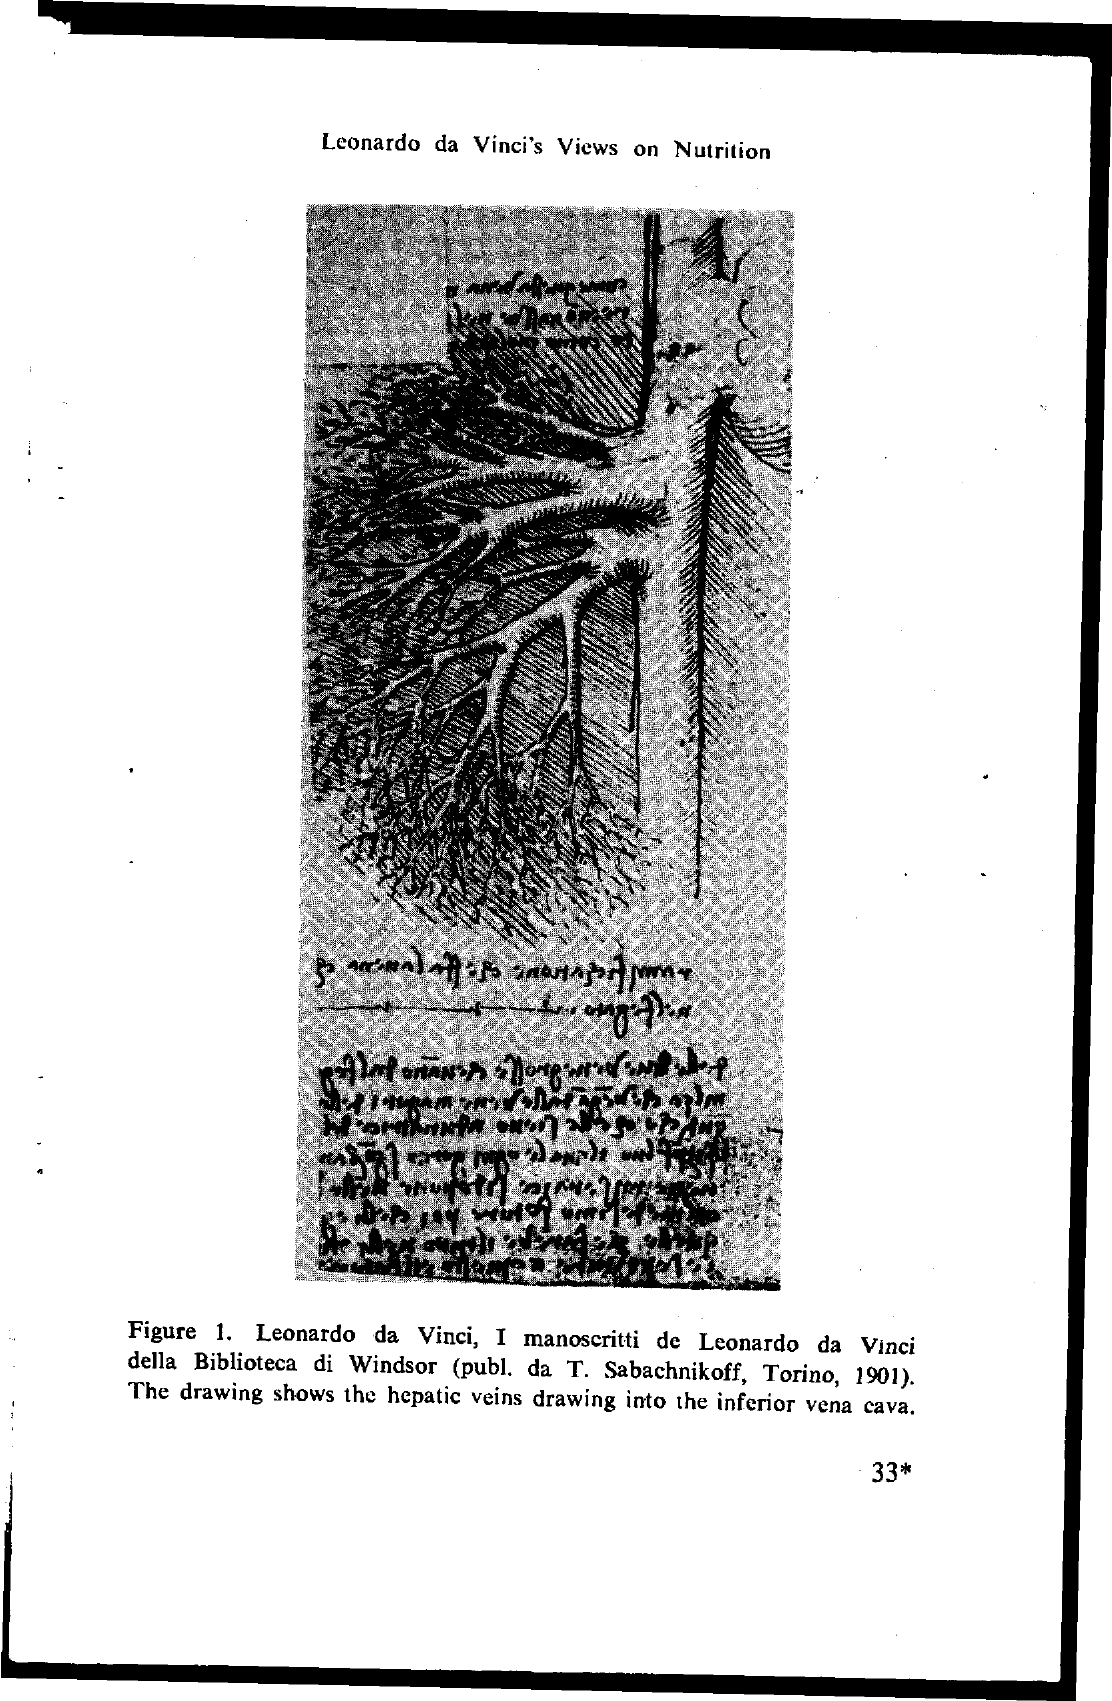What is the title on the page?
Offer a very short reply. Leonardo da Vinci's Views on Nutrition. What is the page number at bottom of the page?
Ensure brevity in your answer.  33*. Whose views on nutrition are given in page?
Keep it short and to the point. Leonardo Da Vinci's. 